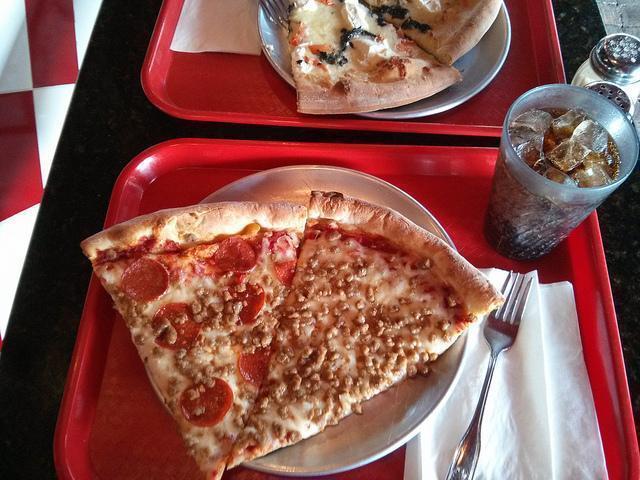Where was this pizza purchased?
Indicate the correct response and explain using: 'Answer: answer
Rationale: rationale.'
Options: Walmart, super market, home cooked, restaurant. Answer: restaurant.
Rationale: The tray where the pizza is on is that of an establishment that sells pizza. 